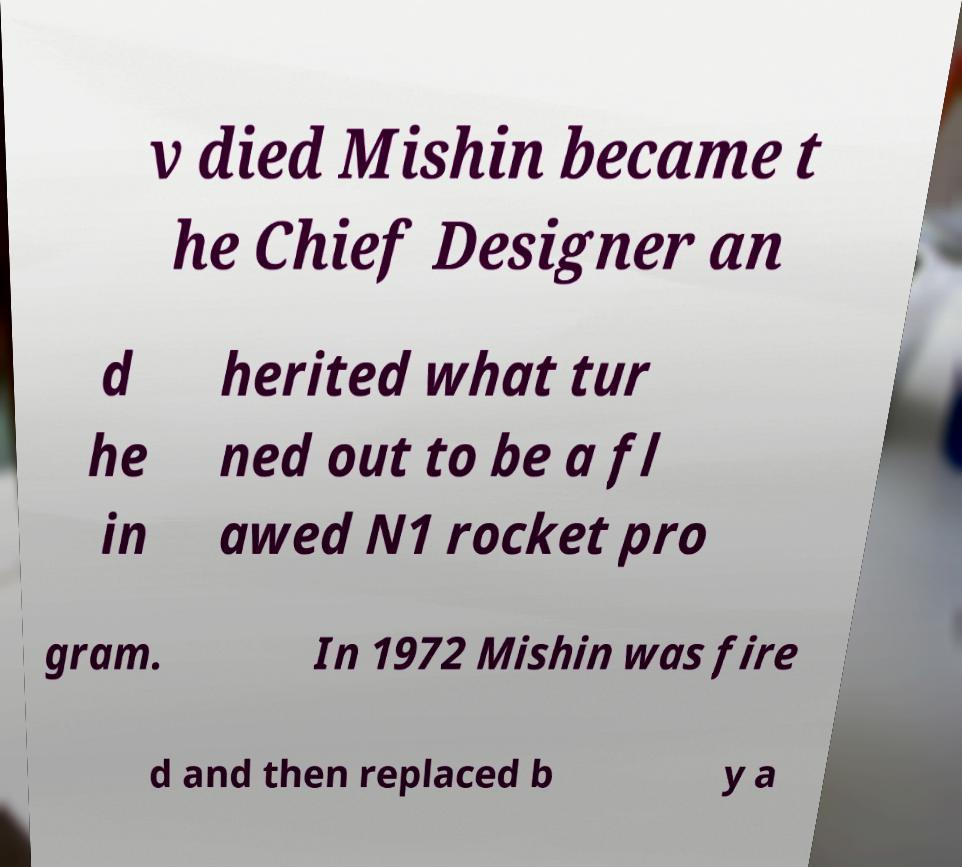Can you accurately transcribe the text from the provided image for me? v died Mishin became t he Chief Designer an d he in herited what tur ned out to be a fl awed N1 rocket pro gram. In 1972 Mishin was fire d and then replaced b y a 